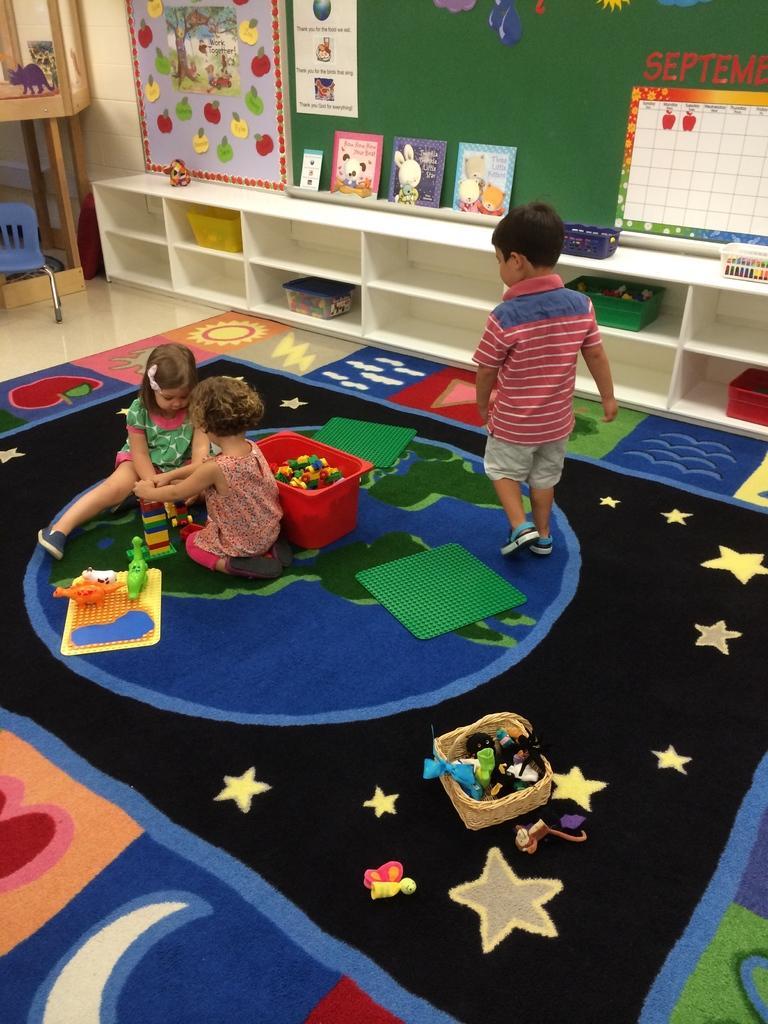Please provide a concise description of this image. In this image we can see two children playing with toys. On the floor there is a carpet and there is another boy. In the back there is a wall. Also there is a cupboard. Inside the cupboard there are baskets. Near to the wall there are books and some other items. 